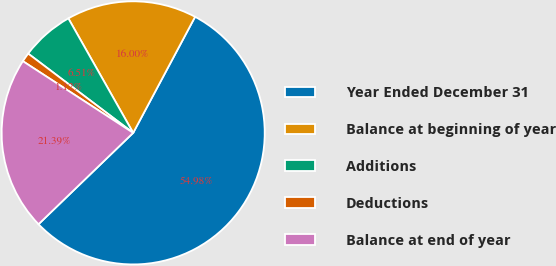Convert chart. <chart><loc_0><loc_0><loc_500><loc_500><pie_chart><fcel>Year Ended December 31<fcel>Balance at beginning of year<fcel>Additions<fcel>Deductions<fcel>Balance at end of year<nl><fcel>54.99%<fcel>16.0%<fcel>6.51%<fcel>1.12%<fcel>21.39%<nl></chart> 